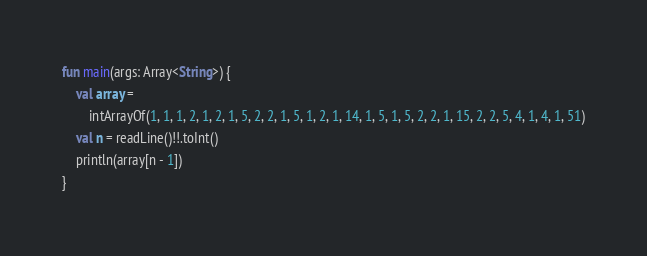<code> <loc_0><loc_0><loc_500><loc_500><_Kotlin_>fun main(args: Array<String>) {
    val array =
        intArrayOf(1, 1, 1, 2, 1, 2, 1, 5, 2, 2, 1, 5, 1, 2, 1, 14, 1, 5, 1, 5, 2, 2, 1, 15, 2, 2, 5, 4, 1, 4, 1, 51)
    val n = readLine()!!.toInt()
    println(array[n - 1])
}</code> 